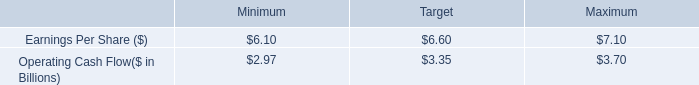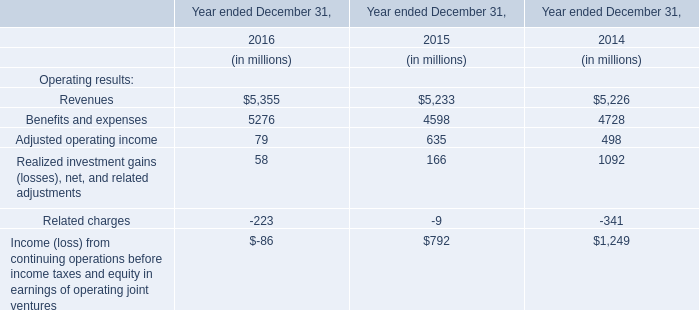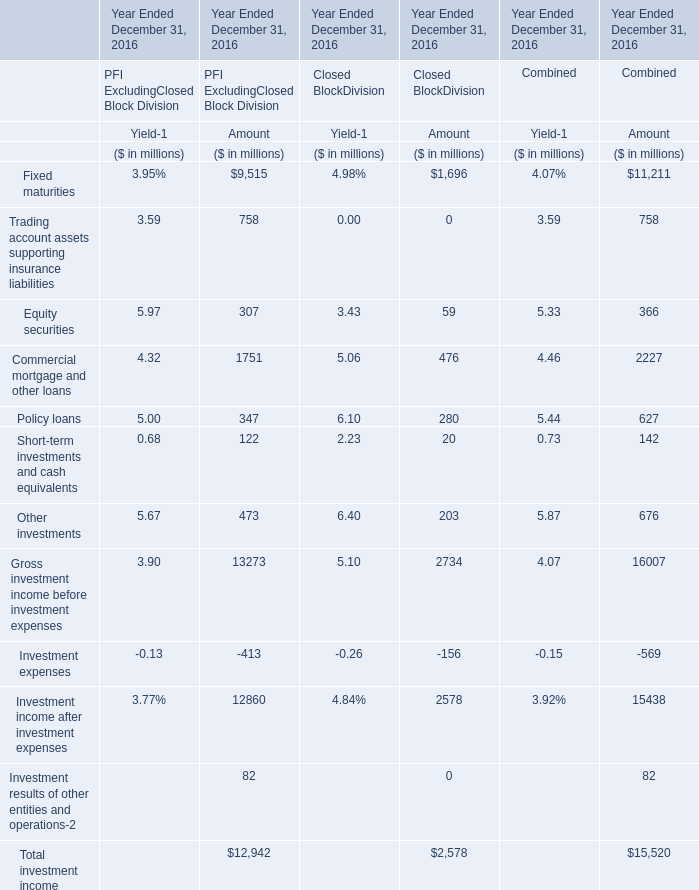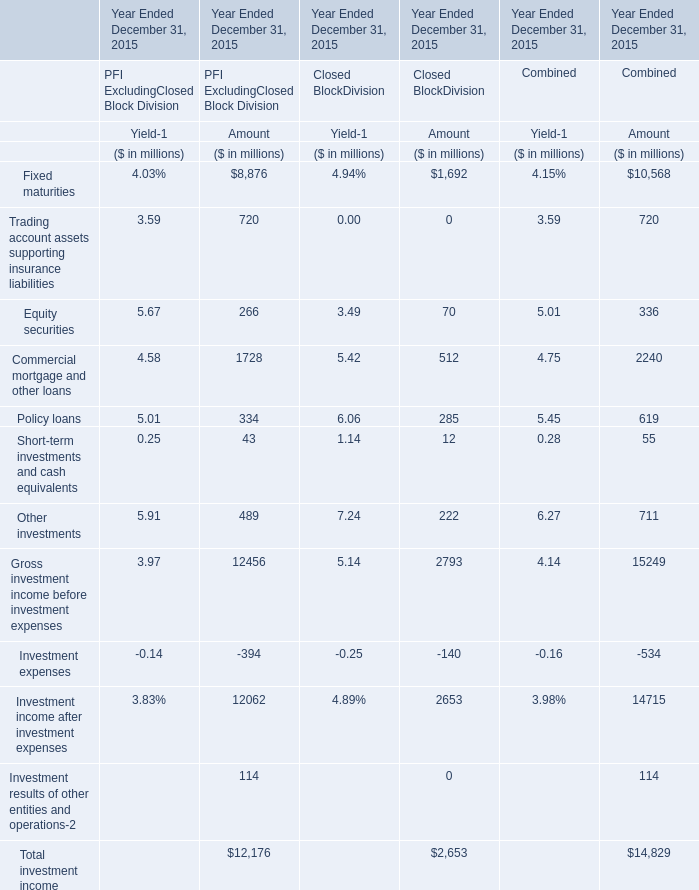Which element exceeds 18 % of total for Closed BlockDivision of Amout ? 
Answer: Fixed maturities, Commercial mortgage and other loans. 